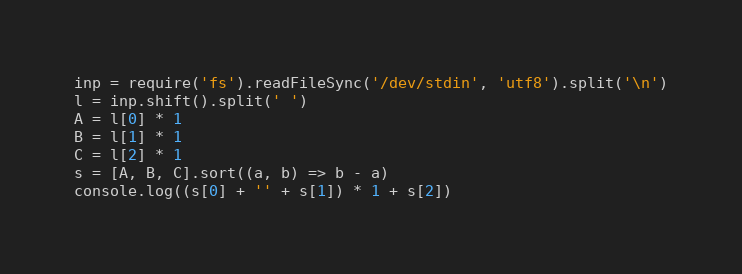<code> <loc_0><loc_0><loc_500><loc_500><_JavaScript_>inp = require('fs').readFileSync('/dev/stdin', 'utf8').split('\n')
l = inp.shift().split(' ')
A = l[0] * 1
B = l[1] * 1
C = l[2] * 1
s = [A, B, C].sort((a, b) => b - a)
console.log((s[0] + '' + s[1]) * 1 + s[2]) 
</code> 